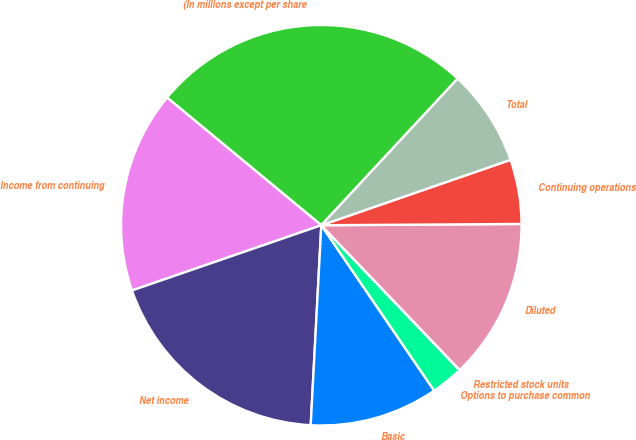Convert chart. <chart><loc_0><loc_0><loc_500><loc_500><pie_chart><fcel>(In millions except per share<fcel>Income from continuing<fcel>Net income<fcel>Basic<fcel>Options to purchase common<fcel>Restricted stock units<fcel>Diluted<fcel>Continuing operations<fcel>Total<nl><fcel>25.91%<fcel>16.28%<fcel>18.87%<fcel>10.37%<fcel>2.6%<fcel>0.01%<fcel>12.96%<fcel>5.19%<fcel>7.78%<nl></chart> 